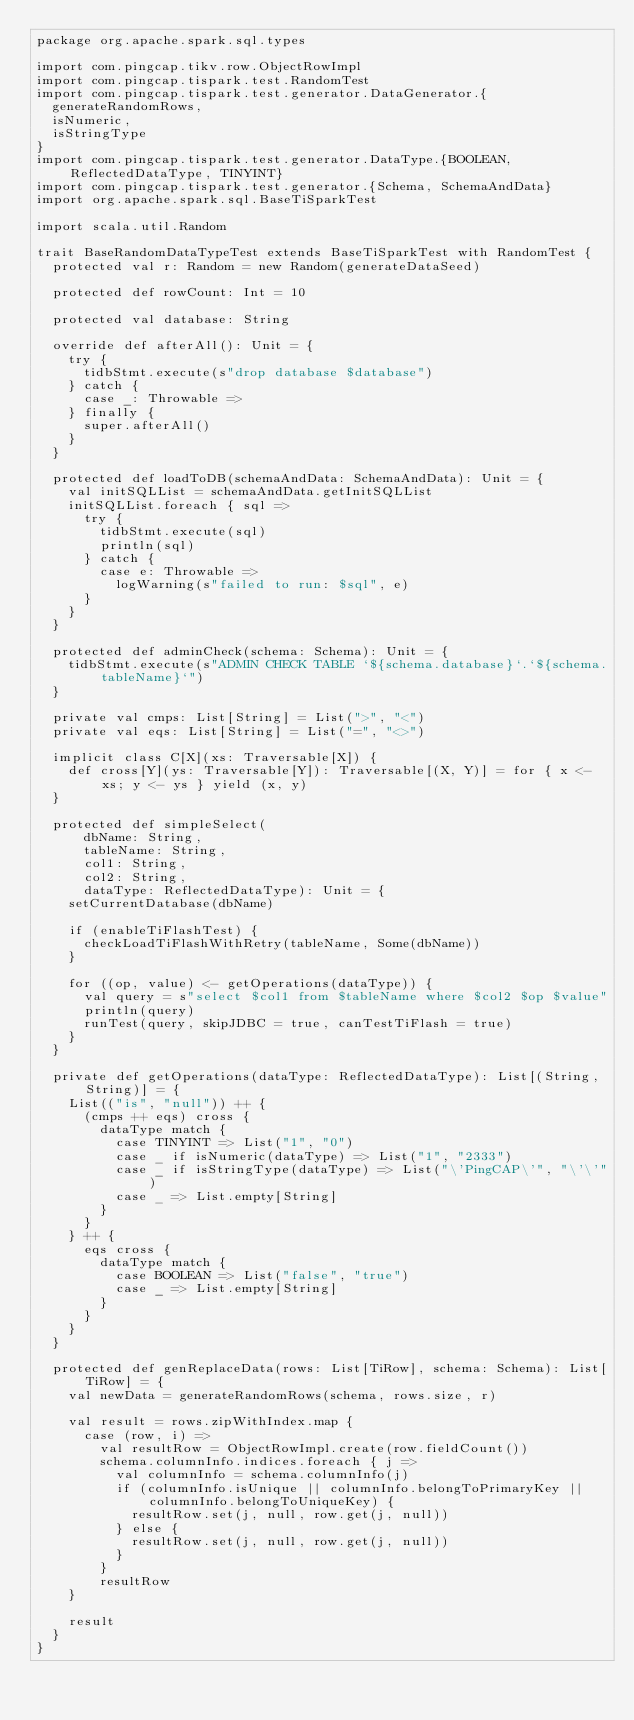Convert code to text. <code><loc_0><loc_0><loc_500><loc_500><_Scala_>package org.apache.spark.sql.types

import com.pingcap.tikv.row.ObjectRowImpl
import com.pingcap.tispark.test.RandomTest
import com.pingcap.tispark.test.generator.DataGenerator.{
  generateRandomRows,
  isNumeric,
  isStringType
}
import com.pingcap.tispark.test.generator.DataType.{BOOLEAN, ReflectedDataType, TINYINT}
import com.pingcap.tispark.test.generator.{Schema, SchemaAndData}
import org.apache.spark.sql.BaseTiSparkTest

import scala.util.Random

trait BaseRandomDataTypeTest extends BaseTiSparkTest with RandomTest {
  protected val r: Random = new Random(generateDataSeed)

  protected def rowCount: Int = 10

  protected val database: String

  override def afterAll(): Unit = {
    try {
      tidbStmt.execute(s"drop database $database")
    } catch {
      case _: Throwable =>
    } finally {
      super.afterAll()
    }
  }

  protected def loadToDB(schemaAndData: SchemaAndData): Unit = {
    val initSQLList = schemaAndData.getInitSQLList
    initSQLList.foreach { sql =>
      try {
        tidbStmt.execute(sql)
        println(sql)
      } catch {
        case e: Throwable =>
          logWarning(s"failed to run: $sql", e)
      }
    }
  }

  protected def adminCheck(schema: Schema): Unit = {
    tidbStmt.execute(s"ADMIN CHECK TABLE `${schema.database}`.`${schema.tableName}`")
  }

  private val cmps: List[String] = List(">", "<")
  private val eqs: List[String] = List("=", "<>")

  implicit class C[X](xs: Traversable[X]) {
    def cross[Y](ys: Traversable[Y]): Traversable[(X, Y)] = for { x <- xs; y <- ys } yield (x, y)
  }

  protected def simpleSelect(
      dbName: String,
      tableName: String,
      col1: String,
      col2: String,
      dataType: ReflectedDataType): Unit = {
    setCurrentDatabase(dbName)

    if (enableTiFlashTest) {
      checkLoadTiFlashWithRetry(tableName, Some(dbName))
    }

    for ((op, value) <- getOperations(dataType)) {
      val query = s"select $col1 from $tableName where $col2 $op $value"
      println(query)
      runTest(query, skipJDBC = true, canTestTiFlash = true)
    }
  }

  private def getOperations(dataType: ReflectedDataType): List[(String, String)] = {
    List(("is", "null")) ++ {
      (cmps ++ eqs) cross {
        dataType match {
          case TINYINT => List("1", "0")
          case _ if isNumeric(dataType) => List("1", "2333")
          case _ if isStringType(dataType) => List("\'PingCAP\'", "\'\'")
          case _ => List.empty[String]
        }
      }
    } ++ {
      eqs cross {
        dataType match {
          case BOOLEAN => List("false", "true")
          case _ => List.empty[String]
        }
      }
    }
  }

  protected def genReplaceData(rows: List[TiRow], schema: Schema): List[TiRow] = {
    val newData = generateRandomRows(schema, rows.size, r)

    val result = rows.zipWithIndex.map {
      case (row, i) =>
        val resultRow = ObjectRowImpl.create(row.fieldCount())
        schema.columnInfo.indices.foreach { j =>
          val columnInfo = schema.columnInfo(j)
          if (columnInfo.isUnique || columnInfo.belongToPrimaryKey || columnInfo.belongToUniqueKey) {
            resultRow.set(j, null, row.get(j, null))
          } else {
            resultRow.set(j, null, row.get(j, null))
          }
        }
        resultRow
    }

    result
  }
}
</code> 